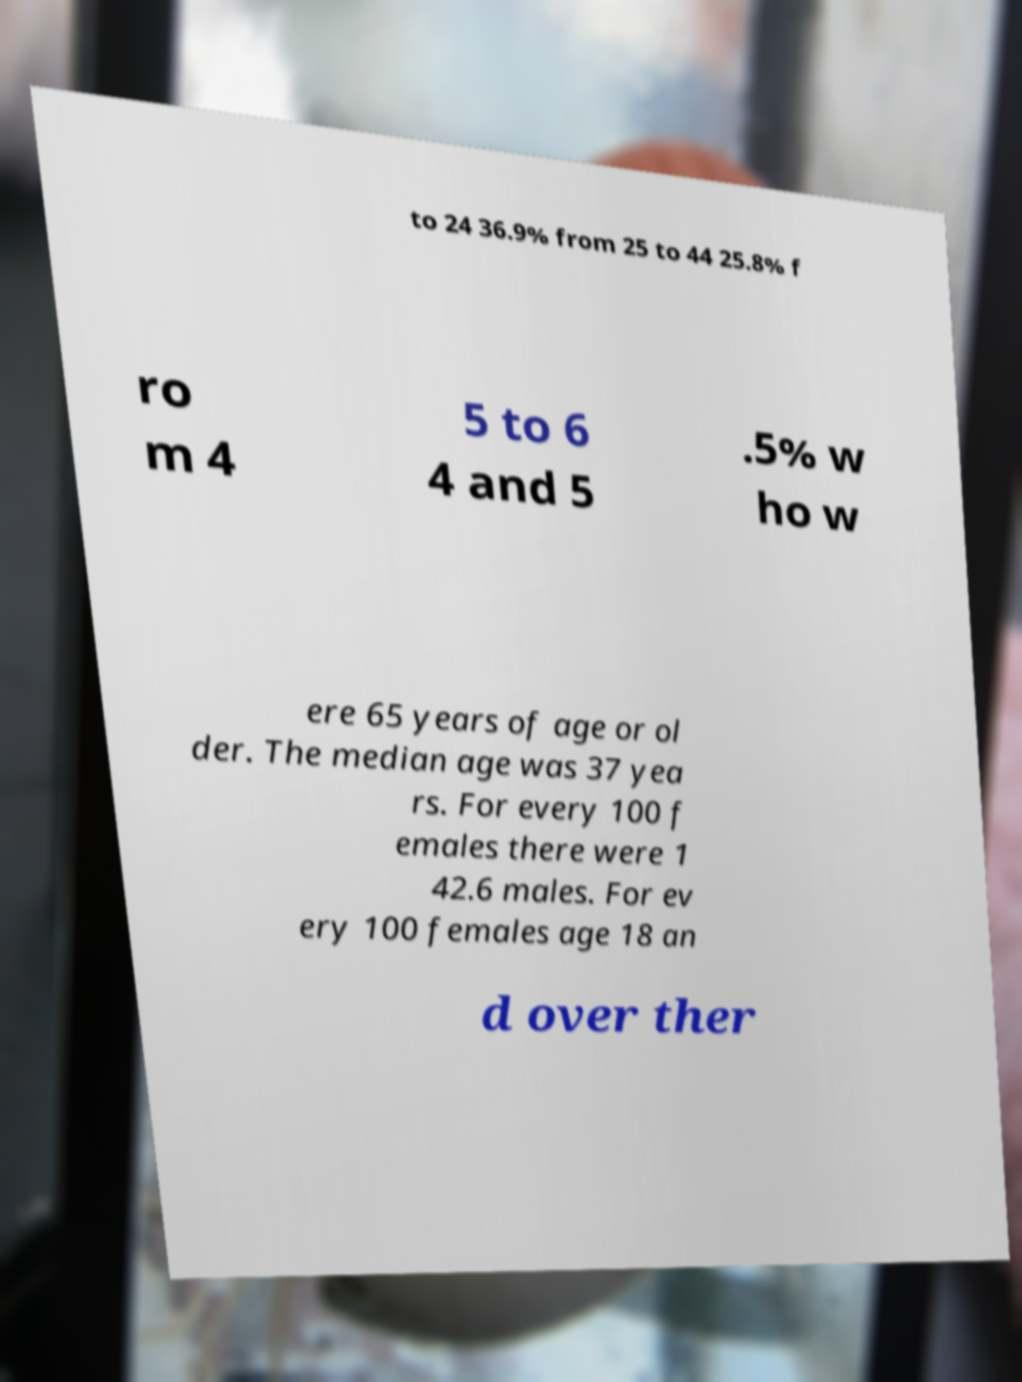Please read and relay the text visible in this image. What does it say? to 24 36.9% from 25 to 44 25.8% f ro m 4 5 to 6 4 and 5 .5% w ho w ere 65 years of age or ol der. The median age was 37 yea rs. For every 100 f emales there were 1 42.6 males. For ev ery 100 females age 18 an d over ther 